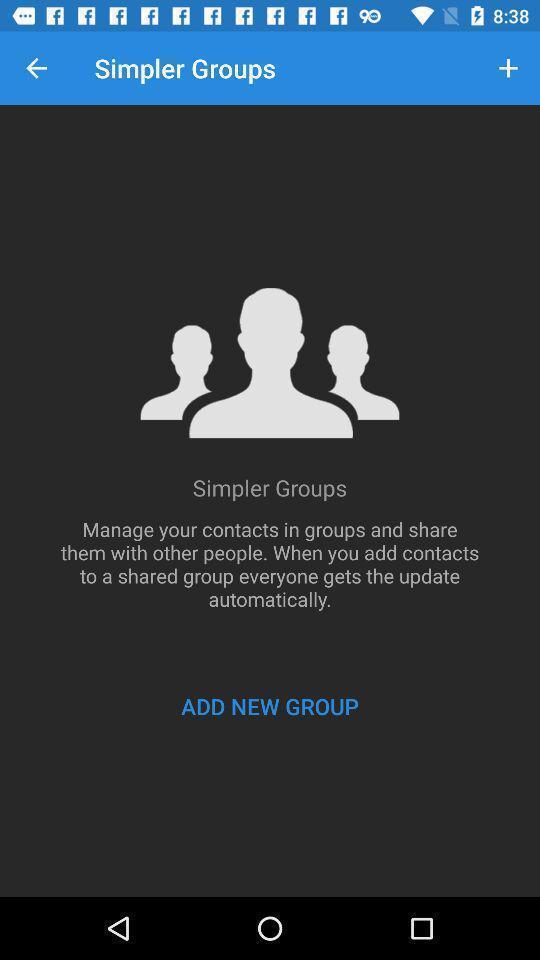Provide a detailed account of this screenshot. Screen shows add simpler groups in a call app. 